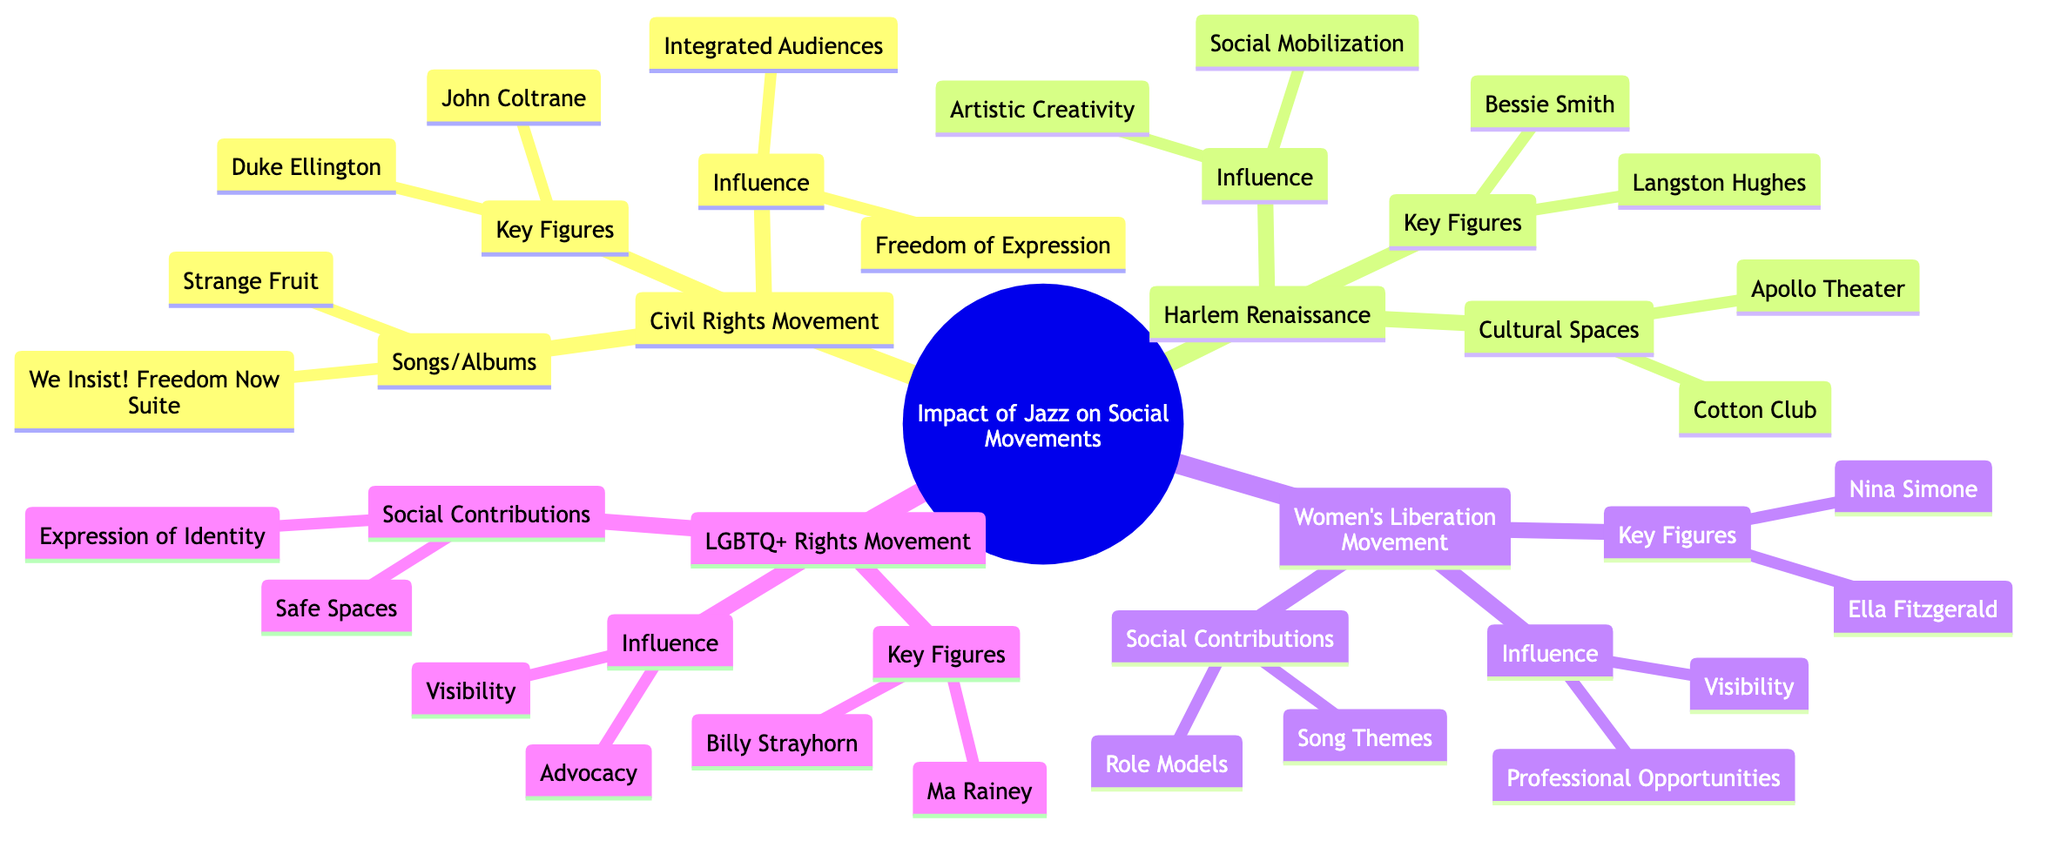What are the Key Figures in the Women's Liberation Movement? The diagram explicitly lists "Key Figures" under the "Women's Liberation Movement" node. Upon examination, these figures are "Ella Fitzgerald" and "Nina Simone."
Answer: Ella Fitzgerald, Nina Simone Which jazz musician is known for the song "Strange Fruit"? The diagram categorizes "Songs/Albums" in the "Civil Rights Movement" section, and "Strange Fruit" is connected to Billie Holiday.
Answer: Billie Holiday How many sections are present in the diagram? The main node "Impact of Jazz on Various Social Movements" branches into four distinct sections: "Civil Rights Movement," "Harlem Renaissance," "Women's Liberation Movement," and "LGBTQ+ Rights Movement." Adding these gives a total of four sections.
Answer: 4 What does "Freedom of Expression" relate to in the diagram? Under the "Influence" node of the "Civil Rights Movement," "Freedom of Expression" is specifically associated, highlighting jazz’s role as a means to voice resistance and demand justice.
Answer: Civil Rights Movement Who is a key figure associated with the LGBTQ+ Rights Movement? The section for the "LGBTQ+ Rights Movement" lists two figures, one being "Billy Strayhorn" and the other "Ma Rainey." You can identify either as a relevant answer.
Answer: Billy Strayhorn What role did the Apollo Theater serve during the Harlem Renaissance? The diagram states that the "Apollo Theater" is categorized under "Cultural Spaces" for the "Harlem Renaissance," serving as a platform for black artists, emphasizing its role in shaping cultural heritage during that period.
Answer: Platform for black artists Which movement did "We Insist! Freedom Now Suite" belong to? This album is listed under "Songs/Albums" in the structure of the "Civil Rights Movement," indicating its thematic connection to this specific social movement.
Answer: Civil Rights Movement What influence does jazz have on social mobilization? Under the "Influence" section of the "Harlem Renaissance," it states that jazz encourages "Social Mobilization" which provides a sense of pride and identity within the community.
Answer: Social Mobilization How is Ella Fitzgerald described in the context of the Women’s Liberation Movement? The diagram under "Key Figures" explains Ella Fitzgerald's role as "Breaking barriers as a leading female voice in jazz," giving insight into her influence on the movement.
Answer: Breaking barriers as a leading female voice in jazz 